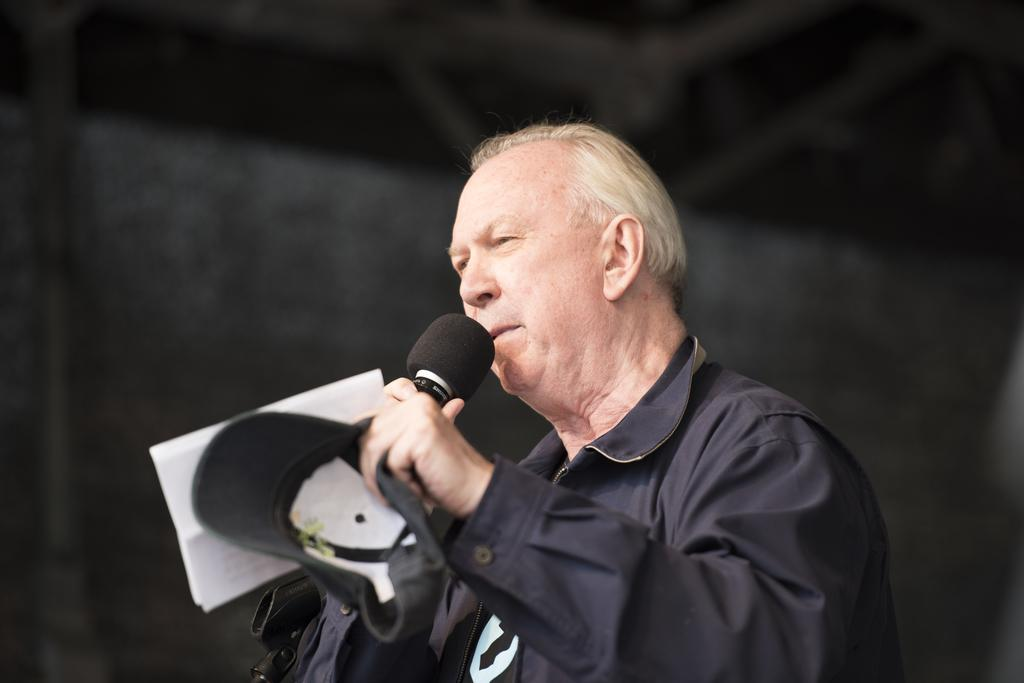What is the man in the image doing? The man is standing, holding a mic, a cap, and a paper, and talking. What is the man wearing in the image? The man is wearing a black jacket. What objects is the man holding in the image? The man is holding a mic, a cap, and a paper. What type of egg is the man holding in the image? There is no egg present in the image; the man is holding a mic, a cap, and a paper. 